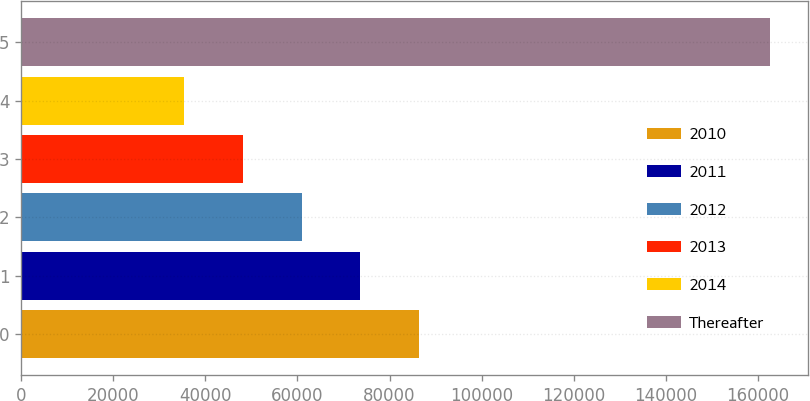Convert chart to OTSL. <chart><loc_0><loc_0><loc_500><loc_500><bar_chart><fcel>2010<fcel>2011<fcel>2012<fcel>2013<fcel>2014<fcel>Thereafter<nl><fcel>86335.8<fcel>73616.1<fcel>60896.4<fcel>48176.7<fcel>35457<fcel>162654<nl></chart> 